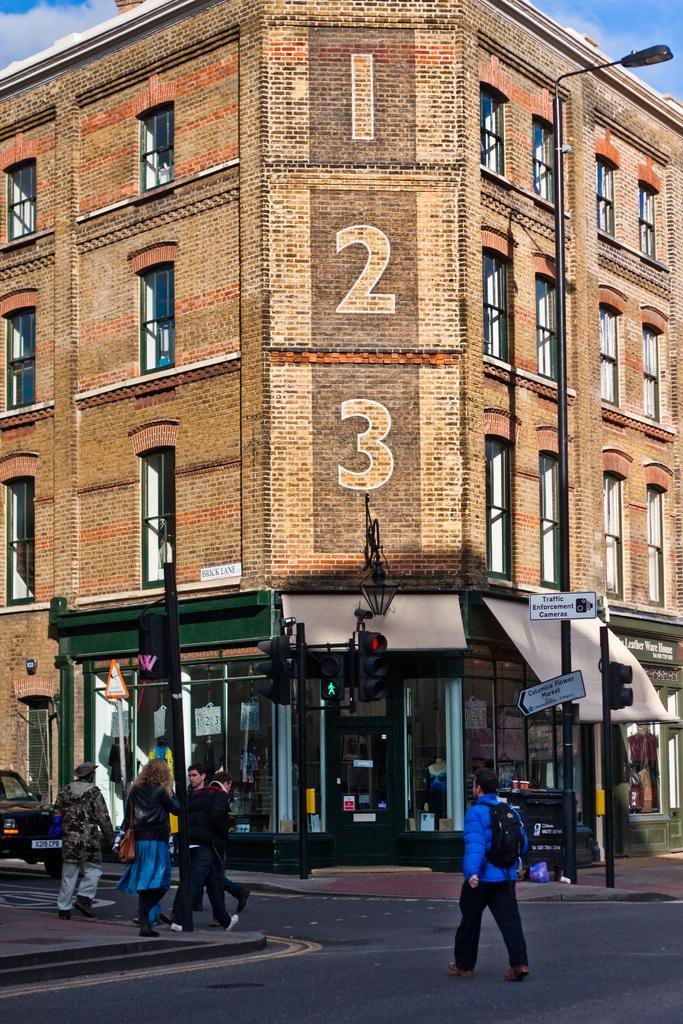In one or two sentences, can you explain what this image depicts? The picture is clicked outside a city. In the foreground of the picture there are footpath, road, poles, signal lights, car and people walking down the road. In the center there is a building. Sky is clear and it is sunny. 